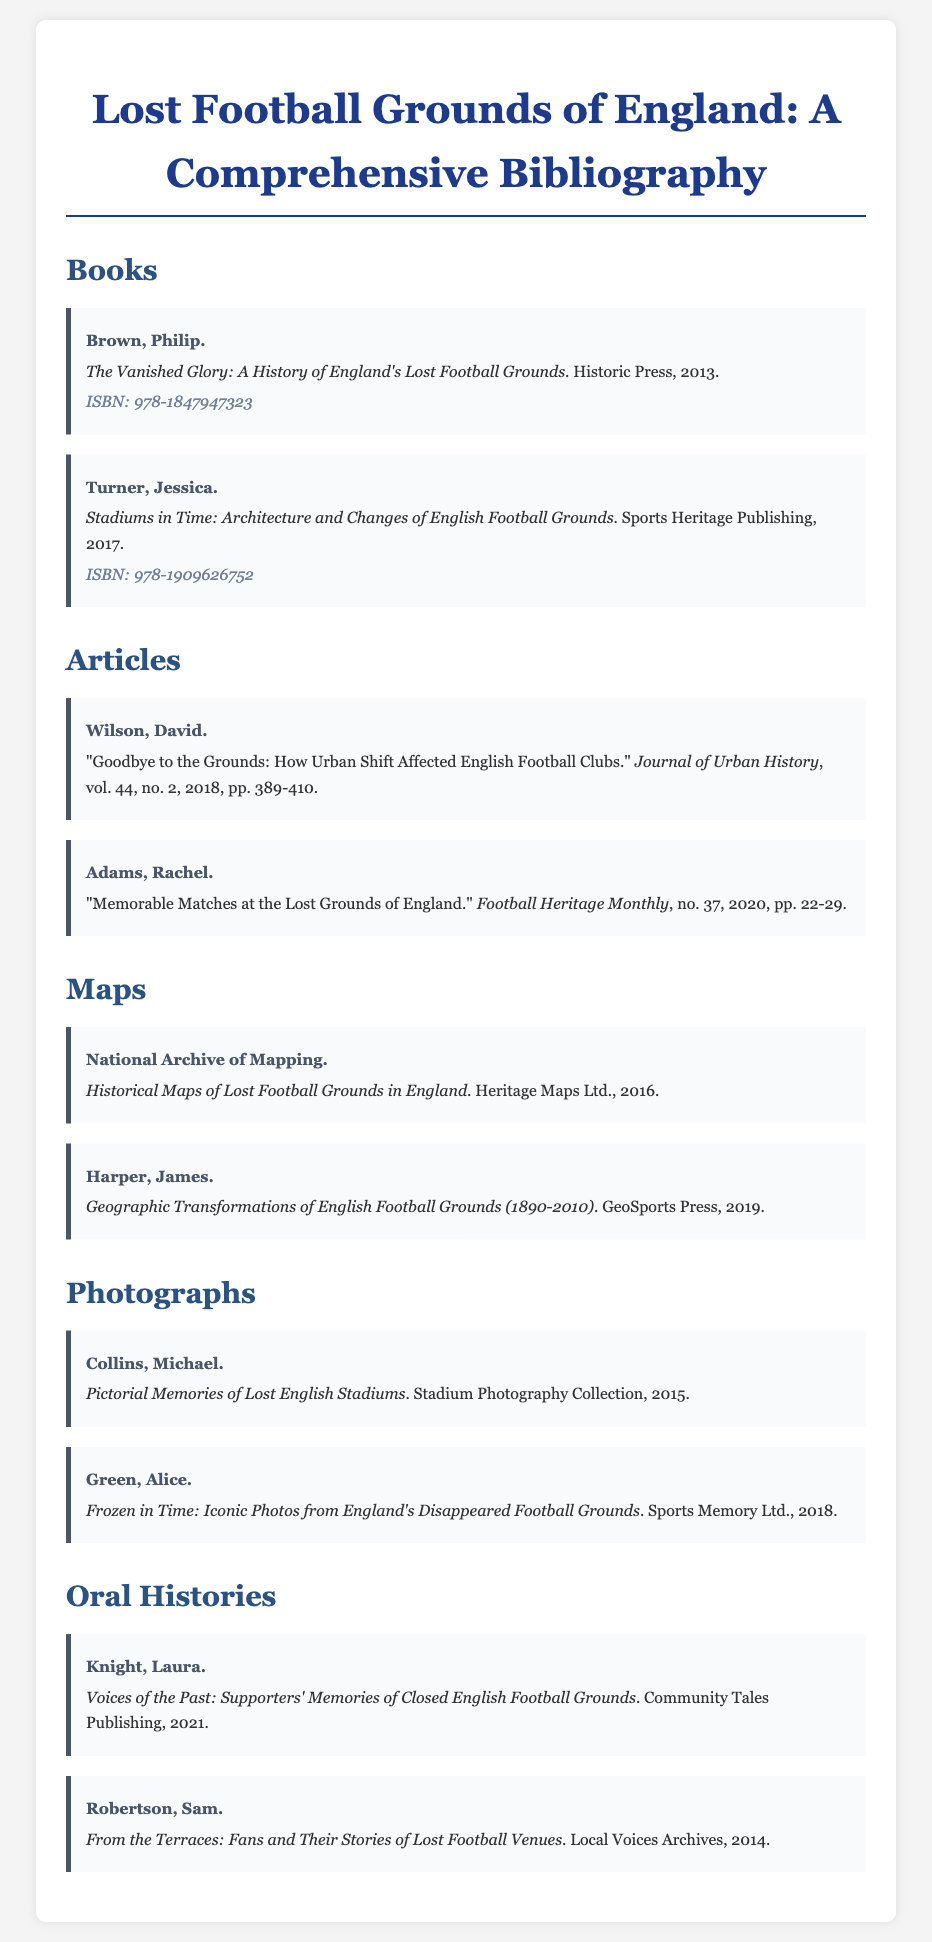What is the title of Philip Brown's book? The title of Philip Brown's book is found in the bibliography section under "Books" and is "The Vanished Glory: A History of England's Lost Football Grounds".
Answer: The Vanished Glory: A History of England's Lost Football Grounds What is the ISBN of Jessica Turner's book? The ISBN is listed next to Jessica Turner's book in the "Books" section of the document.
Answer: 978-1909626752 Who authored the article "Goodbye to the Grounds"? The author of this article is provided in the "Articles" section, specifically noted under that title.
Answer: David Wilson In what year was "Frozen in Time: Iconic Photos from England's Disappeared Football Grounds" published? The publication year for this title is noted in the "Photographs" section of the bibliography.
Answer: 2018 How many entries are listed under "Oral Histories"? This can be determined by counting the number of entries in the "Oral Histories" section of the document.
Answer: 2 What type of document is "Historical Maps of Lost Football Grounds in England"? The type of document is categorized in the "Maps" section of the bibliography.
Answer: Map What is the primary theme of the bibliography? The primary theme can be inferred from the title and content that focuses on lost football grounds in England.
Answer: Lost football grounds 